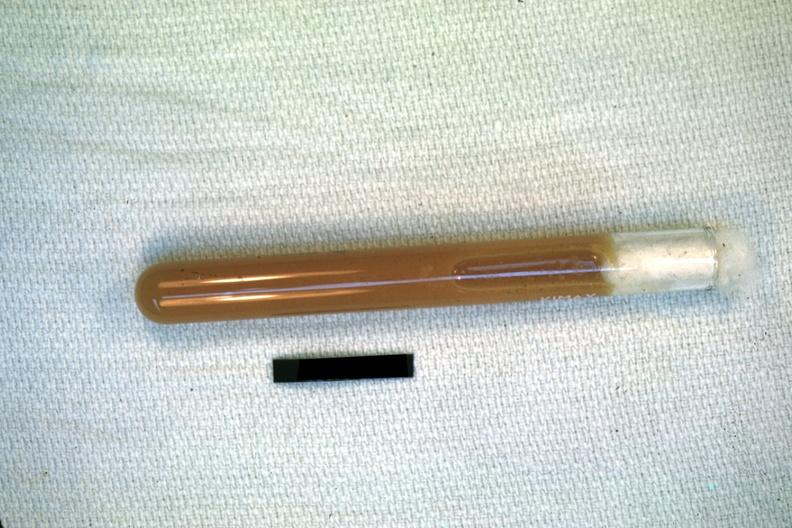s subdiaphragmatic abscess present?
Answer the question using a single word or phrase. No 